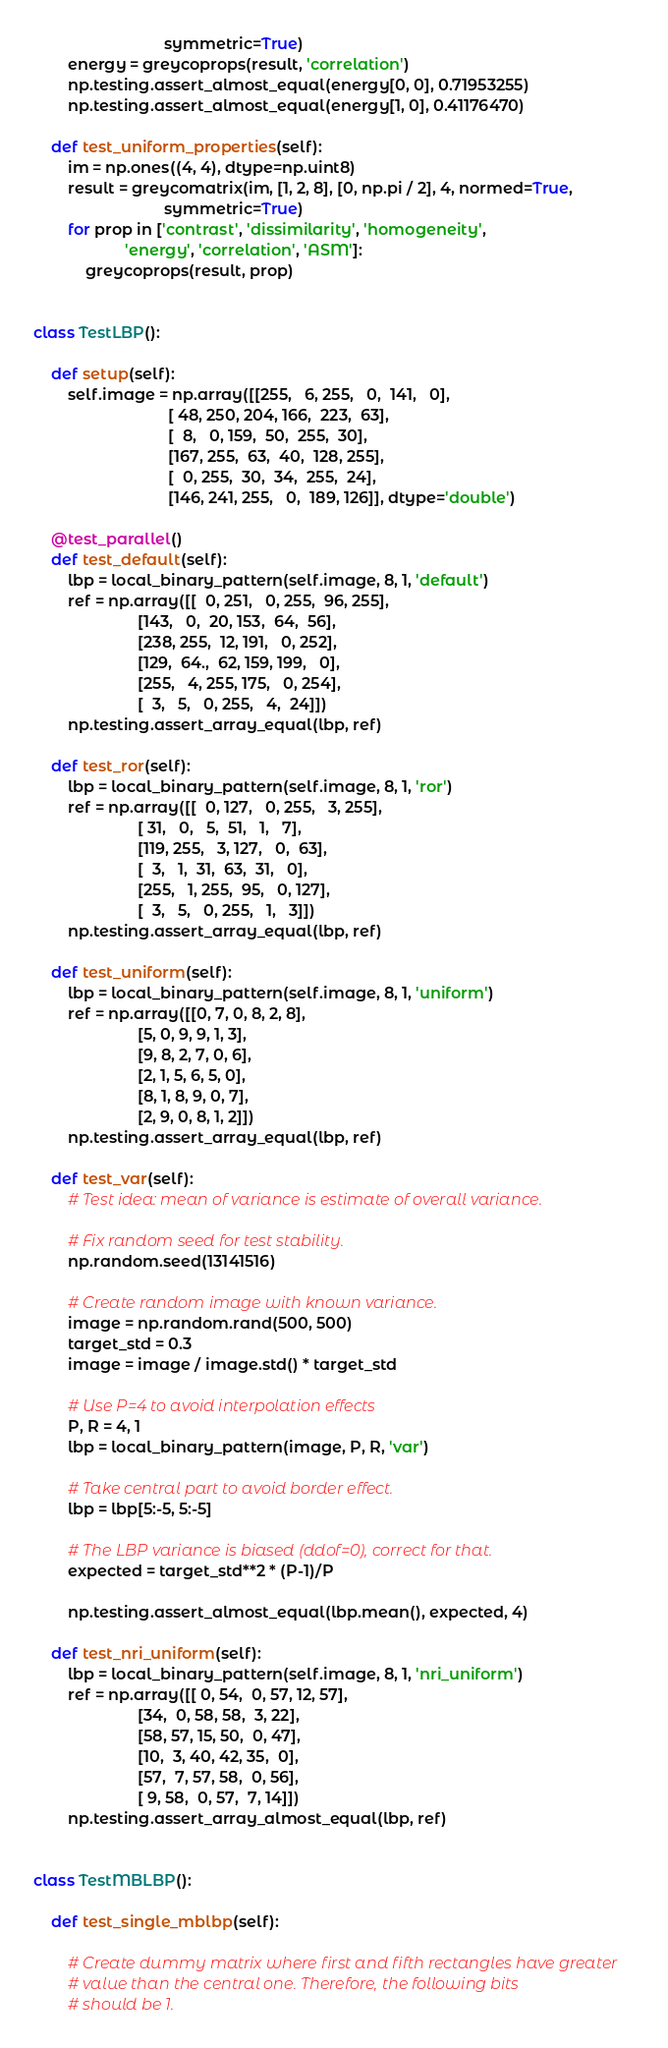Convert code to text. <code><loc_0><loc_0><loc_500><loc_500><_Python_>                              symmetric=True)
        energy = greycoprops(result, 'correlation')
        np.testing.assert_almost_equal(energy[0, 0], 0.71953255)
        np.testing.assert_almost_equal(energy[1, 0], 0.41176470)

    def test_uniform_properties(self):
        im = np.ones((4, 4), dtype=np.uint8)
        result = greycomatrix(im, [1, 2, 8], [0, np.pi / 2], 4, normed=True,
                              symmetric=True)
        for prop in ['contrast', 'dissimilarity', 'homogeneity',
                     'energy', 'correlation', 'ASM']:
            greycoprops(result, prop)


class TestLBP():

    def setup(self):
        self.image = np.array([[255,   6, 255,   0,  141,   0],
                               [ 48, 250, 204, 166,  223,  63],
                               [  8,   0, 159,  50,  255,  30],
                               [167, 255,  63,  40,  128, 255],
                               [  0, 255,  30,  34,  255,  24],
                               [146, 241, 255,   0,  189, 126]], dtype='double')

    @test_parallel()
    def test_default(self):
        lbp = local_binary_pattern(self.image, 8, 1, 'default')
        ref = np.array([[  0, 251,   0, 255,  96, 255],
                        [143,   0,  20, 153,  64,  56],
                        [238, 255,  12, 191,   0, 252],
                        [129,  64.,  62, 159, 199,   0],
                        [255,   4, 255, 175,   0, 254],
                        [  3,   5,   0, 255,   4,  24]])
        np.testing.assert_array_equal(lbp, ref)

    def test_ror(self):
        lbp = local_binary_pattern(self.image, 8, 1, 'ror')
        ref = np.array([[  0, 127,   0, 255,   3, 255],
                        [ 31,   0,   5,  51,   1,   7],
                        [119, 255,   3, 127,   0,  63],
                        [  3,   1,  31,  63,  31,   0],
                        [255,   1, 255,  95,   0, 127],
                        [  3,   5,   0, 255,   1,   3]])
        np.testing.assert_array_equal(lbp, ref)

    def test_uniform(self):
        lbp = local_binary_pattern(self.image, 8, 1, 'uniform')
        ref = np.array([[0, 7, 0, 8, 2, 8],
                        [5, 0, 9, 9, 1, 3],
                        [9, 8, 2, 7, 0, 6],
                        [2, 1, 5, 6, 5, 0],
                        [8, 1, 8, 9, 0, 7],
                        [2, 9, 0, 8, 1, 2]])
        np.testing.assert_array_equal(lbp, ref)

    def test_var(self):
        # Test idea: mean of variance is estimate of overall variance.

        # Fix random seed for test stability.
        np.random.seed(13141516)

        # Create random image with known variance.
        image = np.random.rand(500, 500)
        target_std = 0.3
        image = image / image.std() * target_std

        # Use P=4 to avoid interpolation effects
        P, R = 4, 1
        lbp = local_binary_pattern(image, P, R, 'var')

        # Take central part to avoid border effect.
        lbp = lbp[5:-5, 5:-5]

        # The LBP variance is biased (ddof=0), correct for that.
        expected = target_std**2 * (P-1)/P

        np.testing.assert_almost_equal(lbp.mean(), expected, 4)

    def test_nri_uniform(self):
        lbp = local_binary_pattern(self.image, 8, 1, 'nri_uniform')
        ref = np.array([[ 0, 54,  0, 57, 12, 57],
                        [34,  0, 58, 58,  3, 22],
                        [58, 57, 15, 50,  0, 47],
                        [10,  3, 40, 42, 35,  0],
                        [57,  7, 57, 58,  0, 56],
                        [ 9, 58,  0, 57,  7, 14]])
        np.testing.assert_array_almost_equal(lbp, ref)


class TestMBLBP():

    def test_single_mblbp(self):

        # Create dummy matrix where first and fifth rectangles have greater
        # value than the central one. Therefore, the following bits
        # should be 1.</code> 